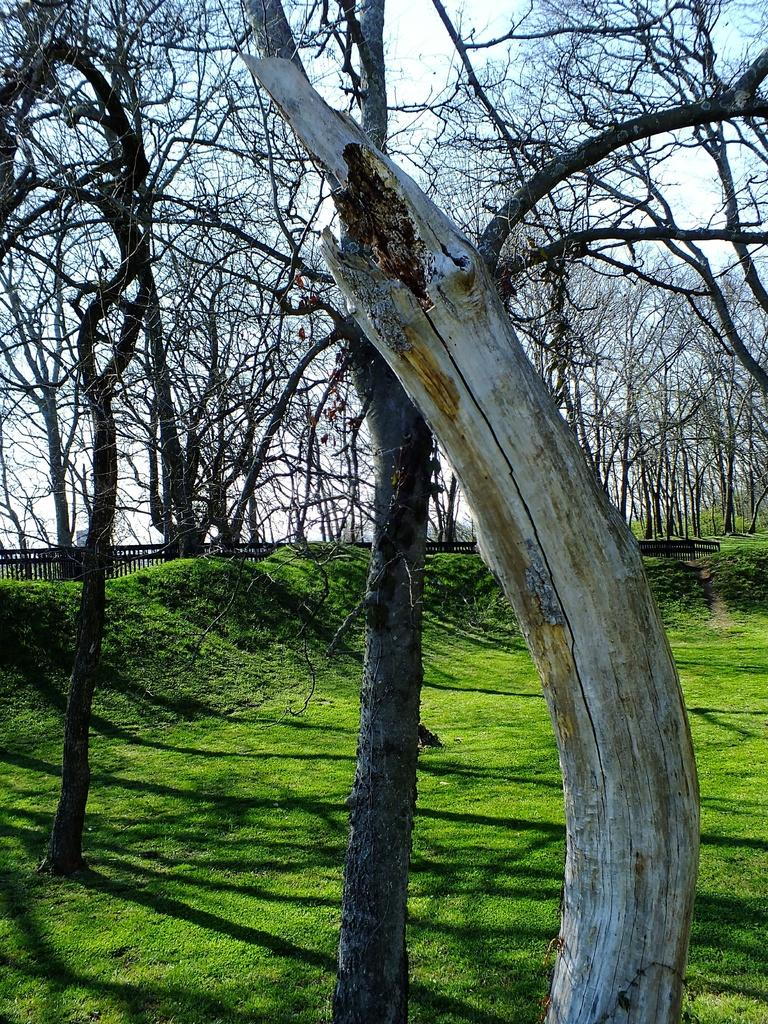What type of vegetation covers the ground in the image? The ground in the image is covered with grass. What can be seen in the image besides the grass? There is a dry tree trunk and dry trees in the image. What type of fencing is visible in the background of the image? There is an iron fencing in the background of the image. What type of bait is being used to catch fish in the image? There is no fishing or bait present in the image. What is the profit margin for the trees in the image? There is no mention of profit or business in the image; it simply depicts trees and a dry tree trunk. 